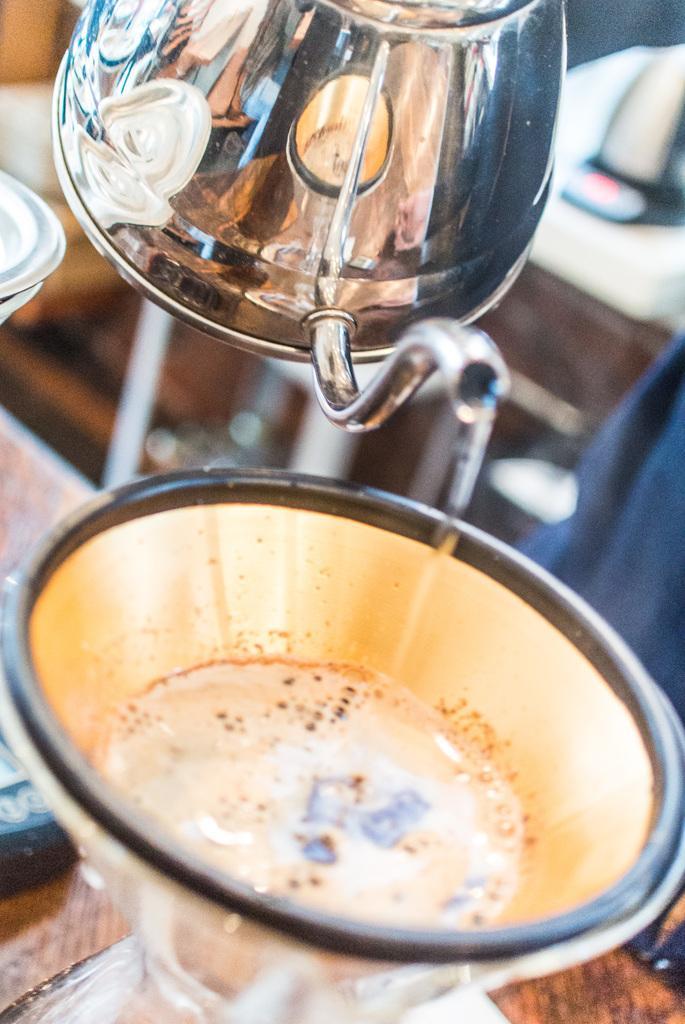Can you describe this image briefly? In this image I can see a glass on the table, kettle, person and a cabinet. This image is taken may be in a hotel. 